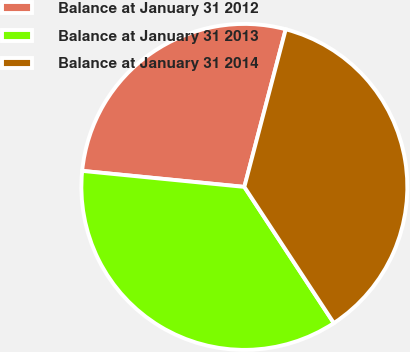Convert chart to OTSL. <chart><loc_0><loc_0><loc_500><loc_500><pie_chart><fcel>Balance at January 31 2012<fcel>Balance at January 31 2013<fcel>Balance at January 31 2014<nl><fcel>27.52%<fcel>35.82%<fcel>36.66%<nl></chart> 